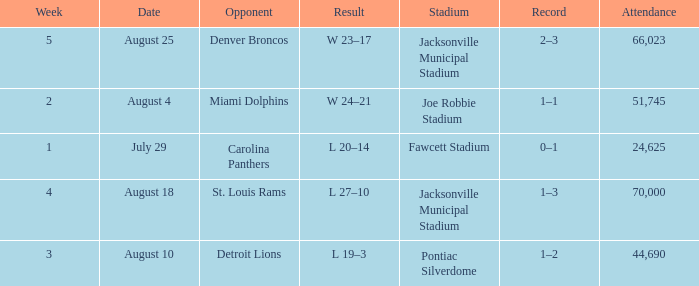WHEN has a Result of w 23–17? August 25. 